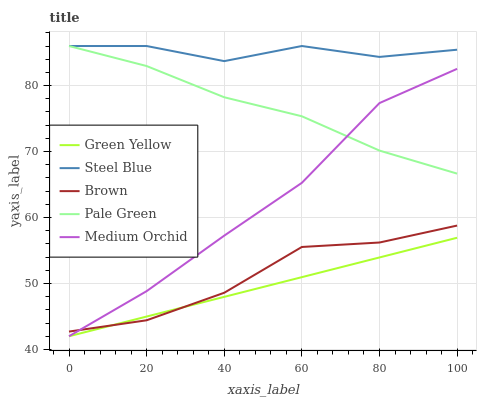Does Green Yellow have the minimum area under the curve?
Answer yes or no. Yes. Does Steel Blue have the maximum area under the curve?
Answer yes or no. Yes. Does Pale Green have the minimum area under the curve?
Answer yes or no. No. Does Pale Green have the maximum area under the curve?
Answer yes or no. No. Is Green Yellow the smoothest?
Answer yes or no. Yes. Is Steel Blue the roughest?
Answer yes or no. Yes. Is Pale Green the smoothest?
Answer yes or no. No. Is Pale Green the roughest?
Answer yes or no. No. Does Green Yellow have the lowest value?
Answer yes or no. Yes. Does Pale Green have the lowest value?
Answer yes or no. No. Does Steel Blue have the highest value?
Answer yes or no. Yes. Does Green Yellow have the highest value?
Answer yes or no. No. Is Brown less than Steel Blue?
Answer yes or no. Yes. Is Pale Green greater than Green Yellow?
Answer yes or no. Yes. Does Green Yellow intersect Medium Orchid?
Answer yes or no. Yes. Is Green Yellow less than Medium Orchid?
Answer yes or no. No. Is Green Yellow greater than Medium Orchid?
Answer yes or no. No. Does Brown intersect Steel Blue?
Answer yes or no. No. 